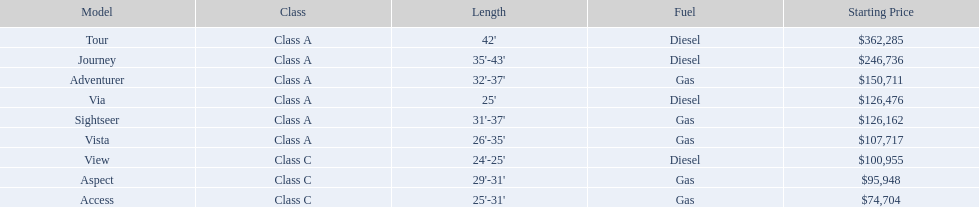What are the charges? $362,285, $246,736, $150,711, $126,476, $126,162, $107,717, $100,955, $95,948, $74,704. What is the peak charge? $362,285. Which variant has this charge? Tour. Which model features the least expensive starting price? Access. Which model comes in with the second highest initial price? Journey. Which model holds the highest price tag in the winnebago industry? Tour. 